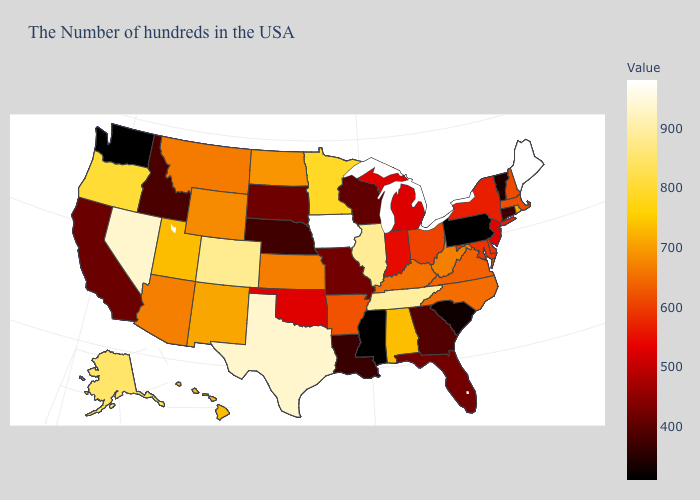Among the states that border Michigan , which have the lowest value?
Answer briefly. Wisconsin. Does the map have missing data?
Keep it brief. No. Does the map have missing data?
Quick response, please. No. Does Rhode Island have the highest value in the USA?
Keep it brief. No. Which states have the highest value in the USA?
Concise answer only. Maine, Iowa. Which states have the lowest value in the MidWest?
Short answer required. Nebraska. 